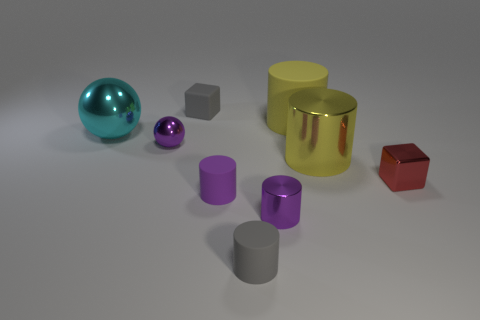How many tiny red cubes are to the left of the tiny gray thing right of the tiny gray cube?
Ensure brevity in your answer.  0. How many purple things are the same shape as the red metallic object?
Your response must be concise. 0. How many large brown cubes are there?
Your answer should be very brief. 0. The big metallic object on the left side of the tiny rubber cube is what color?
Your response must be concise. Cyan. There is a cube on the left side of the gray object that is in front of the large cyan shiny thing; what color is it?
Ensure brevity in your answer.  Gray. There is a metal cylinder that is the same size as the matte cube; what color is it?
Your response must be concise. Purple. What number of shiny objects are on the left side of the metallic block and behind the tiny purple matte thing?
Make the answer very short. 3. The tiny metal thing that is the same color as the small metallic cylinder is what shape?
Keep it short and to the point. Sphere. What material is the small thing that is to the left of the tiny gray rubber cylinder and in front of the small sphere?
Your answer should be compact. Rubber. Are there fewer gray cubes that are to the left of the cyan shiny sphere than shiny objects behind the tiny purple metal cylinder?
Give a very brief answer. Yes. 